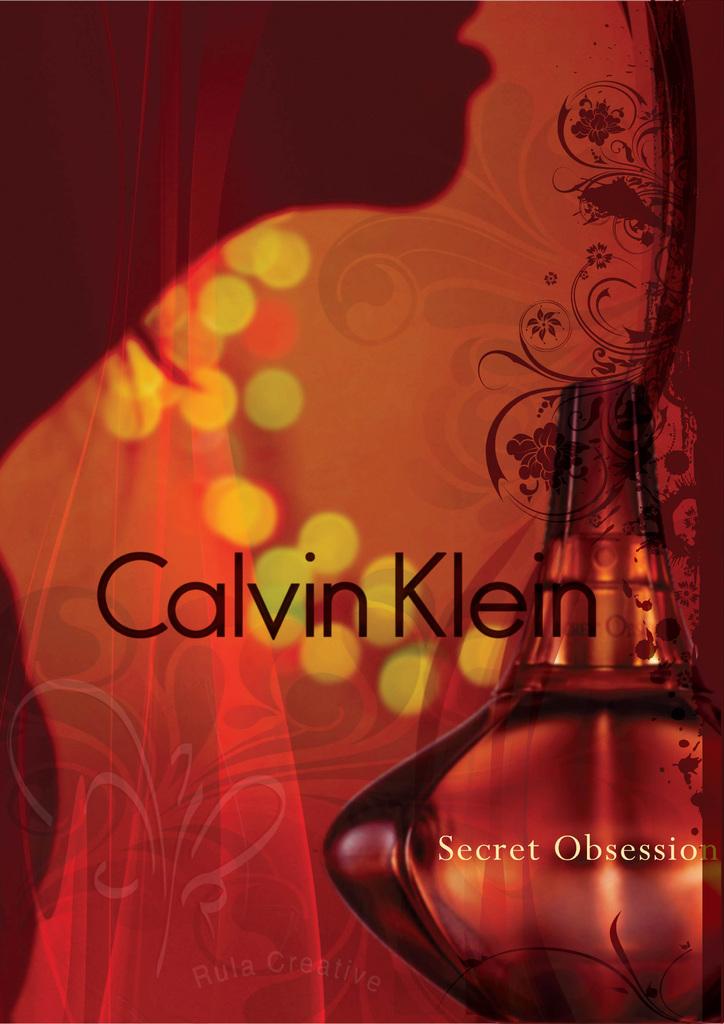What is the name of the cologne/perfume?
Your response must be concise. Secret obsession. What brand is that/?
Ensure brevity in your answer.  Calvin klein. 